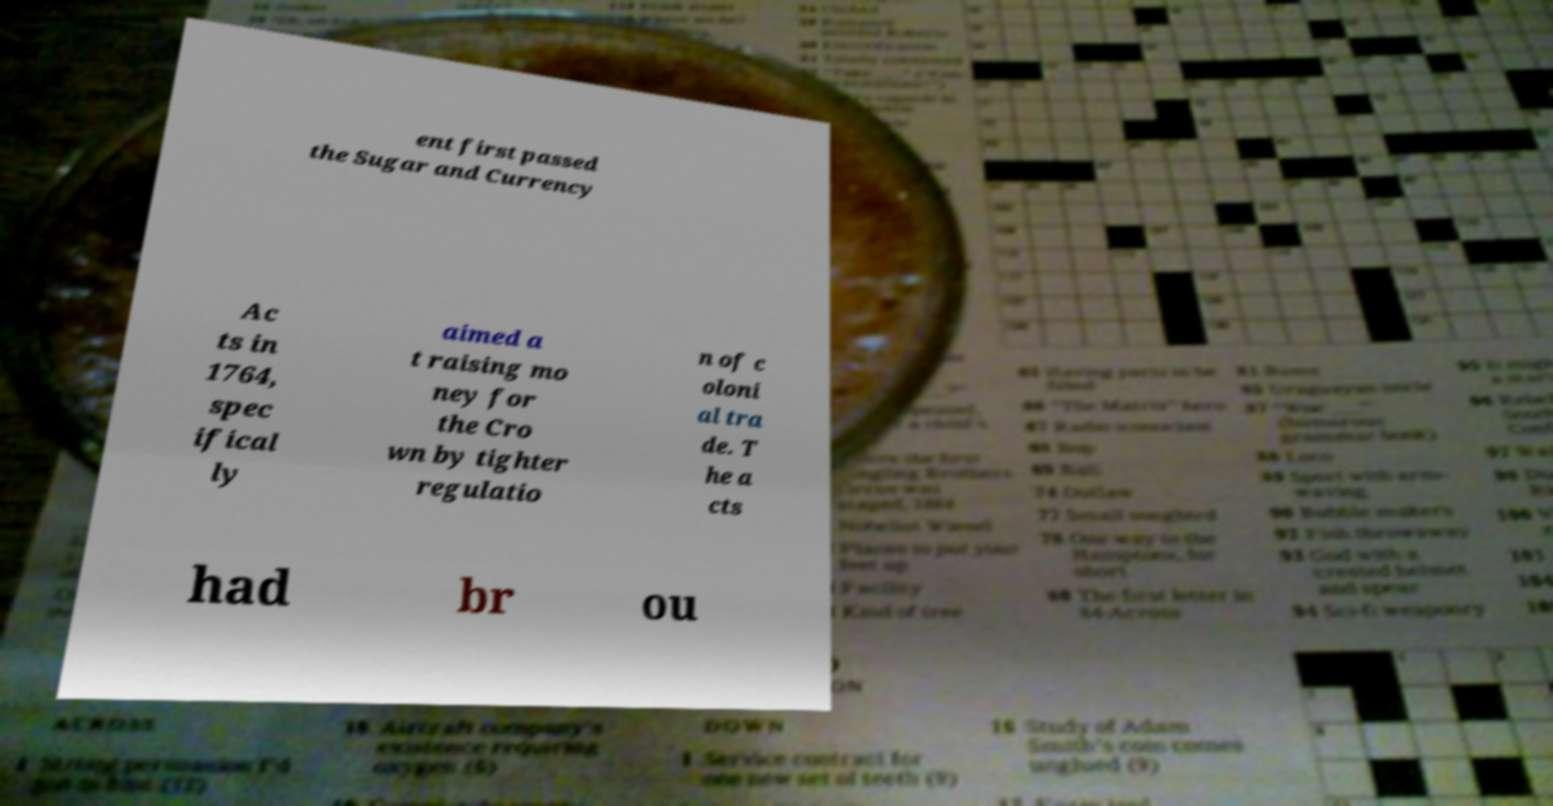There's text embedded in this image that I need extracted. Can you transcribe it verbatim? ent first passed the Sugar and Currency Ac ts in 1764, spec ifical ly aimed a t raising mo ney for the Cro wn by tighter regulatio n of c oloni al tra de. T he a cts had br ou 